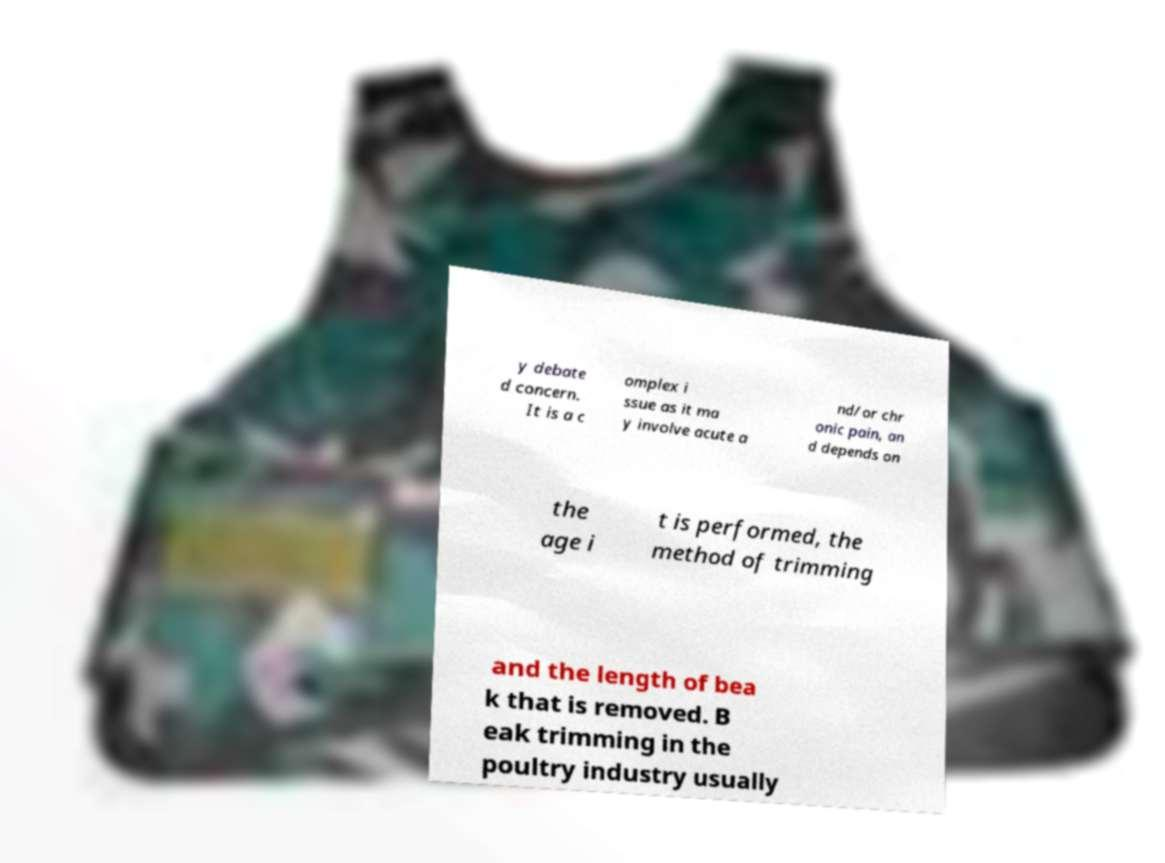What messages or text are displayed in this image? I need them in a readable, typed format. y debate d concern. It is a c omplex i ssue as it ma y involve acute a nd/or chr onic pain, an d depends on the age i t is performed, the method of trimming and the length of bea k that is removed. B eak trimming in the poultry industry usually 